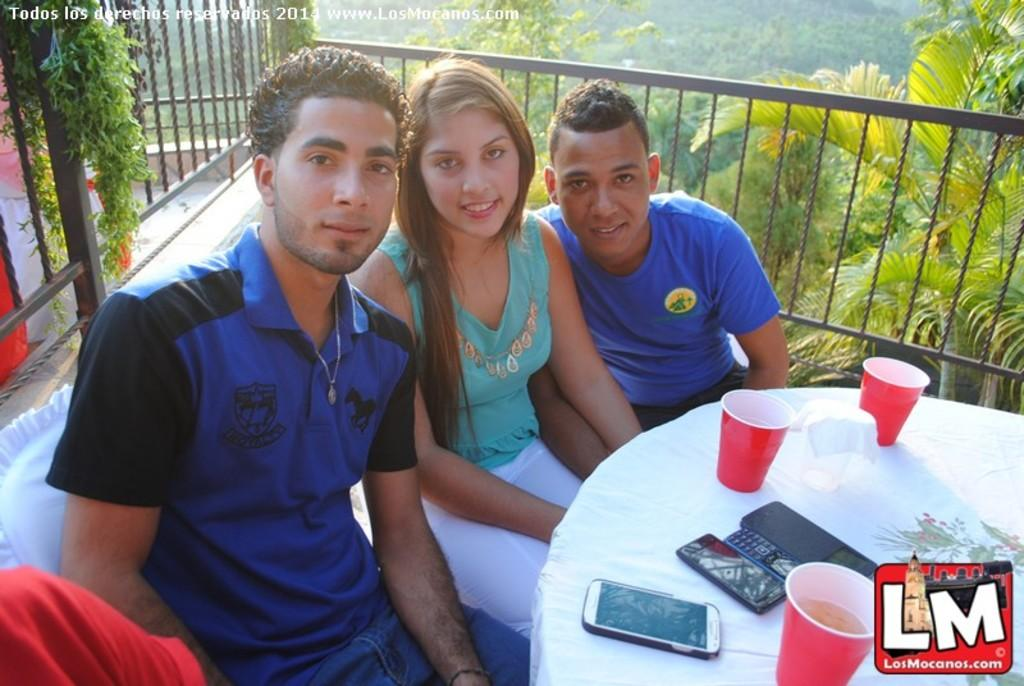How many people are sitting in chairs in the image? There are three people sitting in chairs in the image. What is in front of the people sitting in chairs? There is a white table in front of them. What objects can be seen on the table? Mobile phones and a red cup are present on the table. What can be seen in the background of the image? Trees are visible in the background. What type of lettuce is being used as a tablecloth in the image? There is no lettuce present in the image, and it is not being used as a tablecloth. 